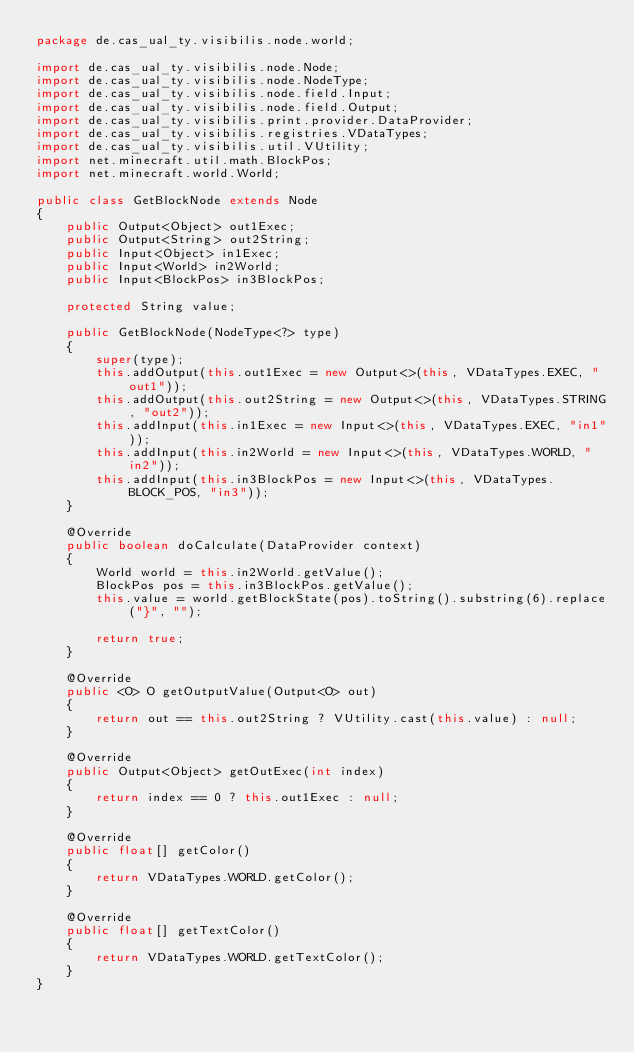Convert code to text. <code><loc_0><loc_0><loc_500><loc_500><_Java_>package de.cas_ual_ty.visibilis.node.world;

import de.cas_ual_ty.visibilis.node.Node;
import de.cas_ual_ty.visibilis.node.NodeType;
import de.cas_ual_ty.visibilis.node.field.Input;
import de.cas_ual_ty.visibilis.node.field.Output;
import de.cas_ual_ty.visibilis.print.provider.DataProvider;
import de.cas_ual_ty.visibilis.registries.VDataTypes;
import de.cas_ual_ty.visibilis.util.VUtility;
import net.minecraft.util.math.BlockPos;
import net.minecraft.world.World;

public class GetBlockNode extends Node
{
    public Output<Object> out1Exec;
    public Output<String> out2String;
    public Input<Object> in1Exec;
    public Input<World> in2World;
    public Input<BlockPos> in3BlockPos;
    
    protected String value;
    
    public GetBlockNode(NodeType<?> type)
    {
        super(type);
        this.addOutput(this.out1Exec = new Output<>(this, VDataTypes.EXEC, "out1"));
        this.addOutput(this.out2String = new Output<>(this, VDataTypes.STRING, "out2"));
        this.addInput(this.in1Exec = new Input<>(this, VDataTypes.EXEC, "in1"));
        this.addInput(this.in2World = new Input<>(this, VDataTypes.WORLD, "in2"));
        this.addInput(this.in3BlockPos = new Input<>(this, VDataTypes.BLOCK_POS, "in3"));
    }
    
    @Override
    public boolean doCalculate(DataProvider context)
    {
        World world = this.in2World.getValue();
        BlockPos pos = this.in3BlockPos.getValue();
        this.value = world.getBlockState(pos).toString().substring(6).replace("}", "");
        
        return true;
    }
    
    @Override
    public <O> O getOutputValue(Output<O> out)
    {
        return out == this.out2String ? VUtility.cast(this.value) : null;
    }
    
    @Override
    public Output<Object> getOutExec(int index)
    {
        return index == 0 ? this.out1Exec : null;
    }
    
    @Override
    public float[] getColor()
    {
        return VDataTypes.WORLD.getColor();
    }
    
    @Override
    public float[] getTextColor()
    {
        return VDataTypes.WORLD.getTextColor();
    }
}
</code> 